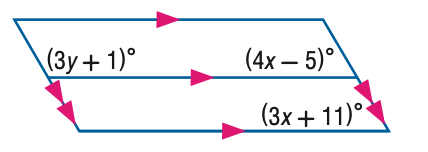Question: Find y in the figure.
Choices:
A. 20
B. 30
C. 40
D. 50
Answer with the letter. Answer: C Question: Find x in the figure.
Choices:
A. 12
B. 16
C. 20
D. 32
Answer with the letter. Answer: B 